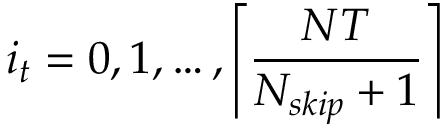Convert formula to latex. <formula><loc_0><loc_0><loc_500><loc_500>i _ { t } = 0 , 1 , \dots , \left \lceil \frac { N T } { N _ { s k i p } + 1 } \right \rceil</formula> 